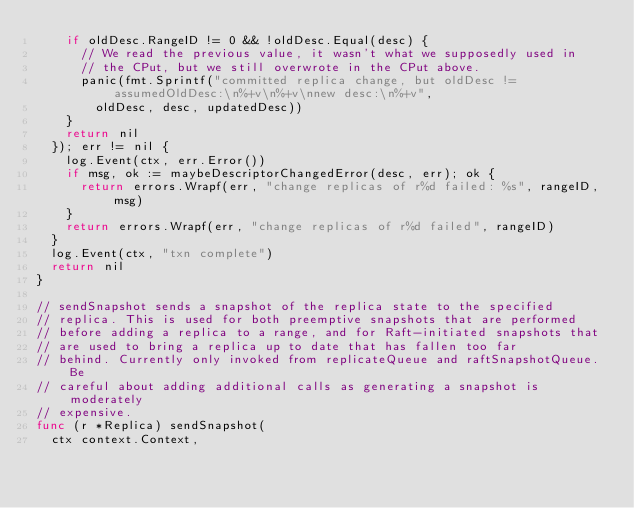Convert code to text. <code><loc_0><loc_0><loc_500><loc_500><_Go_>		if oldDesc.RangeID != 0 && !oldDesc.Equal(desc) {
			// We read the previous value, it wasn't what we supposedly used in
			// the CPut, but we still overwrote in the CPut above.
			panic(fmt.Sprintf("committed replica change, but oldDesc != assumedOldDesc:\n%+v\n%+v\nnew desc:\n%+v",
				oldDesc, desc, updatedDesc))
		}
		return nil
	}); err != nil {
		log.Event(ctx, err.Error())
		if msg, ok := maybeDescriptorChangedError(desc, err); ok {
			return errors.Wrapf(err, "change replicas of r%d failed: %s", rangeID, msg)
		}
		return errors.Wrapf(err, "change replicas of r%d failed", rangeID)
	}
	log.Event(ctx, "txn complete")
	return nil
}

// sendSnapshot sends a snapshot of the replica state to the specified
// replica. This is used for both preemptive snapshots that are performed
// before adding a replica to a range, and for Raft-initiated snapshots that
// are used to bring a replica up to date that has fallen too far
// behind. Currently only invoked from replicateQueue and raftSnapshotQueue. Be
// careful about adding additional calls as generating a snapshot is moderately
// expensive.
func (r *Replica) sendSnapshot(
	ctx context.Context,</code> 